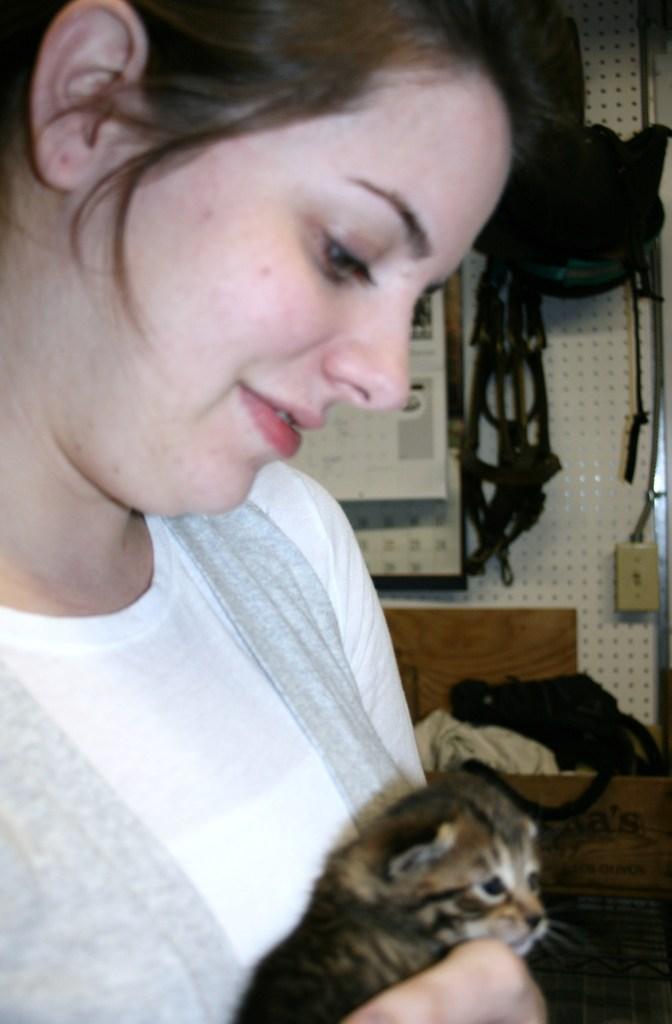Please provide a concise description of this image. In the center of the image, we can see a lady holding cat and in the background, there are bags hanging and there is a board placed on the wall and there is a cot. 